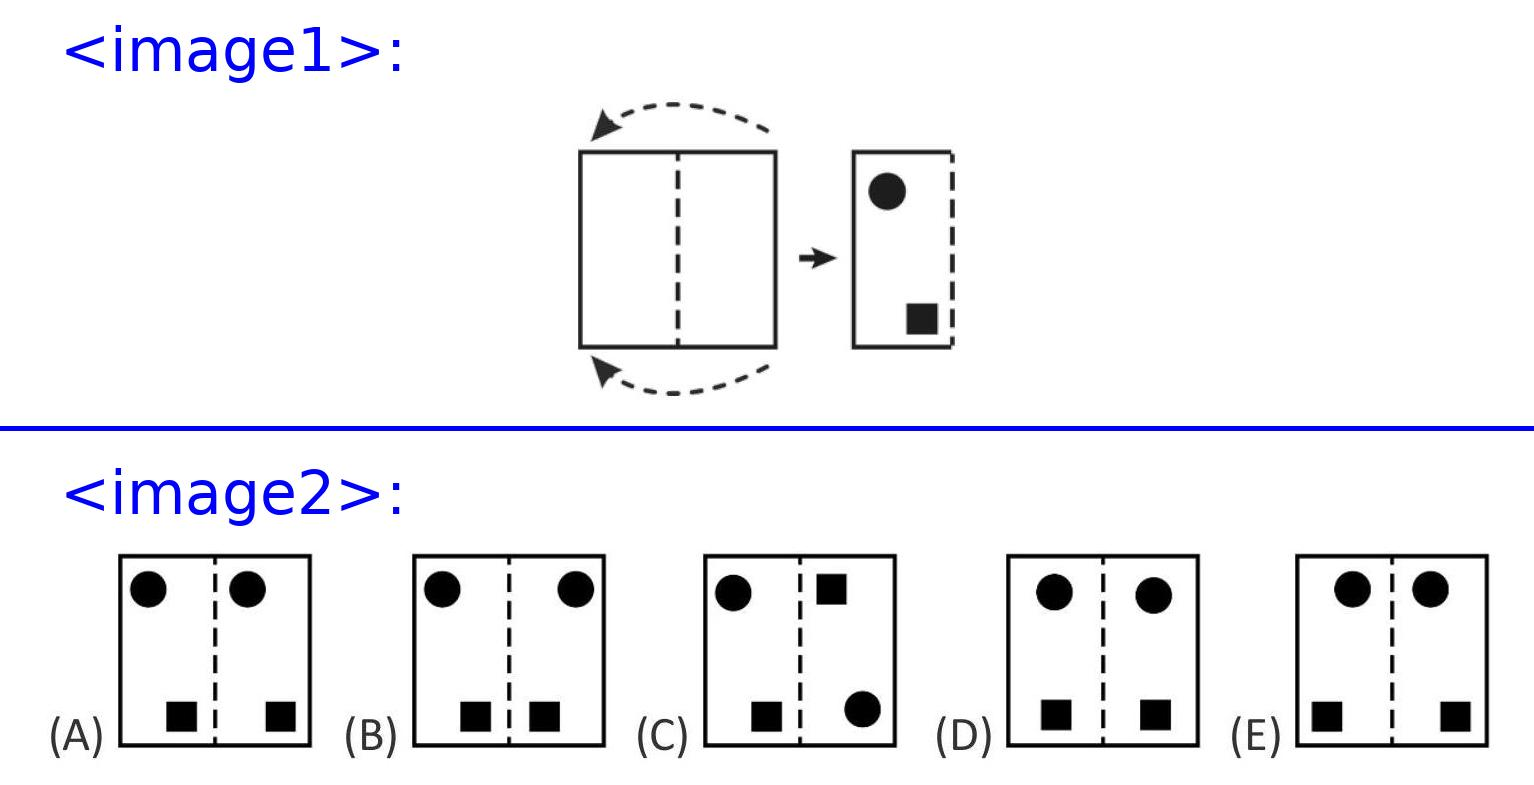If Susi had folded the paper in three parts instead of in half, and then stamped near the edges, what might the pattern look like? If the paper was folded in thirds and Susi stamped near each edge, upon unfolding, there would potentially be three symmetrical sets of holes. The pattern might appear as three groups of holes spaced evenly across the length of the paper, each mirroring its counterparts along the fold lines. This new symmetry would be more complex compared to the simple mirror image in the two-fold scenario. 